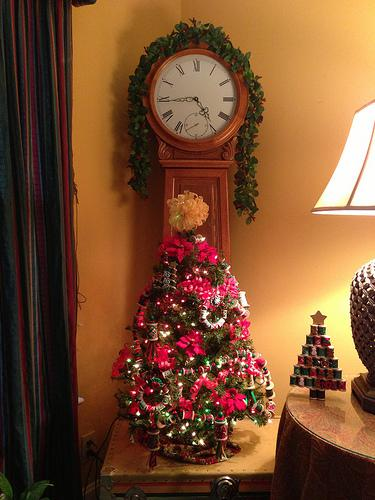Question: what is decorated?
Choices:
A. Windows.
B. Banister.
C. Tree.
D. Doorway.
Answer with the letter. Answer: C Question: who took the picture?
Choices:
A. Man.
B. Woman.
C. Boy.
D. Girl.
Answer with the letter. Answer: A Question: when was the picture taken?
Choices:
A. Dawn.
B. Nighttime.
C. Dusk.
D. Noon.
Answer with the letter. Answer: B Question: how many trees?
Choices:
A. 2.
B. 1.
C. 3.
D. 4.
Answer with the letter. Answer: A Question: what is black?
Choices:
A. Shoes.
B. Numbers on clock.
C. Bench.
D. Door.
Answer with the letter. Answer: B 